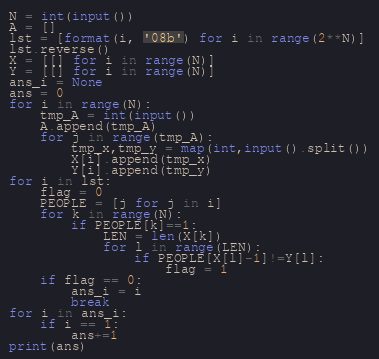<code> <loc_0><loc_0><loc_500><loc_500><_Python_>N = int(input())
A = []
lst = [format(i, '08b') for i in range(2**N)]
lst.reverse()
X = [[] for i in range(N)]
Y = [[] for i in range(N)]
ans_i = None
ans = 0
for i in range(N):
    tmp_A = int(input())
    A.append(tmp_A)
    for j in range(tmp_A):
        tmp_x,tmp_y = map(int,input().split())
        X[i].append(tmp_x)
        Y[i].append(tmp_y)
for i in lst:
    flag = 0
    PEOPLE = [j for j in i]
    for k in range(N):
        if PEOPLE[k]==1:
            LEN = len(X[k])
            for l in range(LEN):
                if PEOPLE[X[l]-1]!=Y[l]:
                    flag = 1
    if flag == 0:
        ans_i = i
        break
for i in ans_i:
    if i == 1:
        ans+=1
print(ans)</code> 